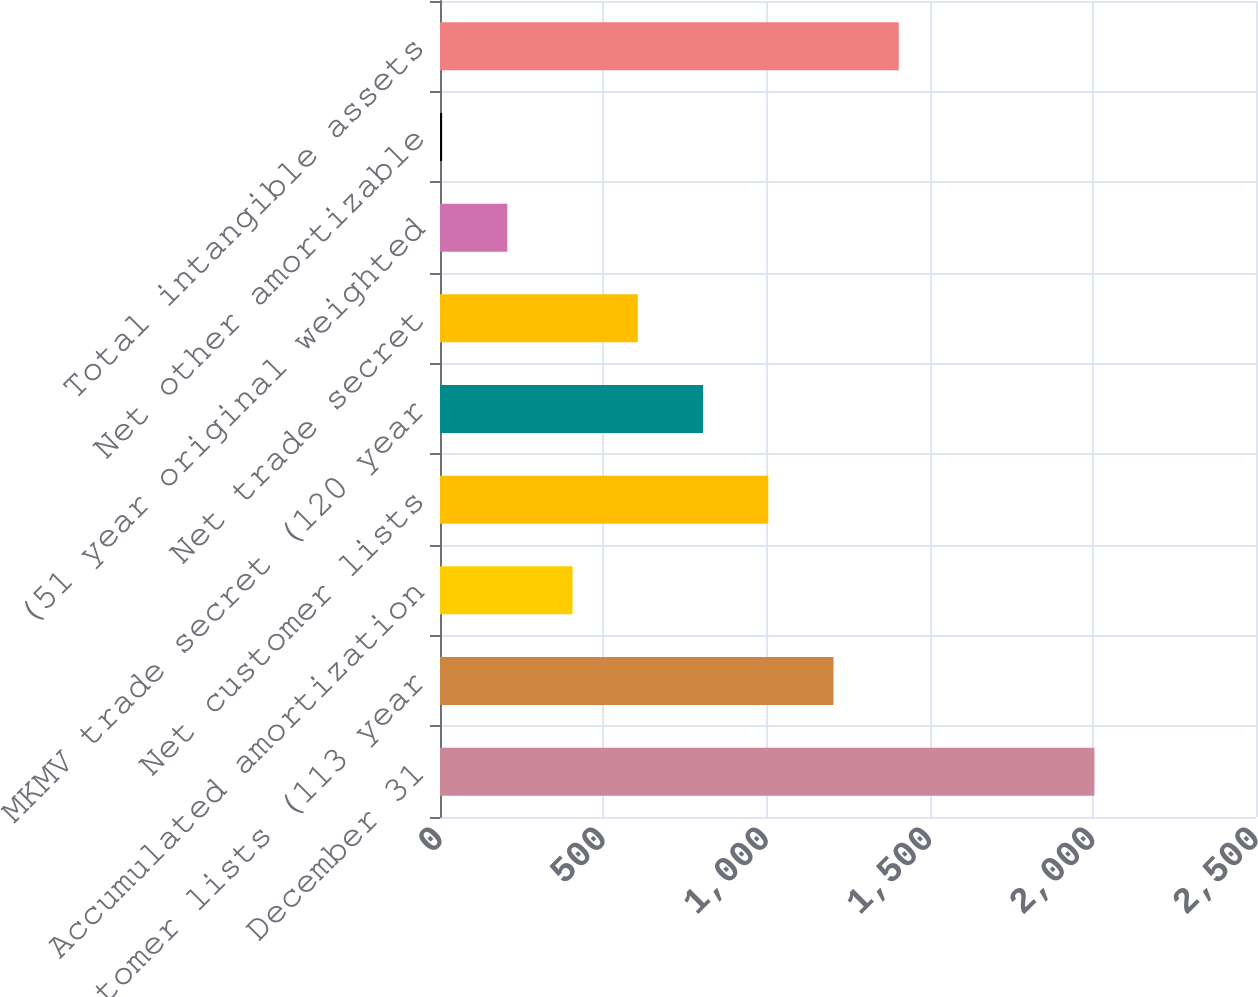<chart> <loc_0><loc_0><loc_500><loc_500><bar_chart><fcel>December 31<fcel>Customer lists (113 year<fcel>Accumulated amortization<fcel>Net customer lists<fcel>MKMV trade secret (120 year<fcel>Net trade secret<fcel>(51 year original weighted<fcel>Net other amortizable<fcel>Total intangible assets<nl><fcel>2005<fcel>1205.6<fcel>406.2<fcel>1005.75<fcel>805.9<fcel>606.05<fcel>206.35<fcel>6.5<fcel>1405.45<nl></chart> 